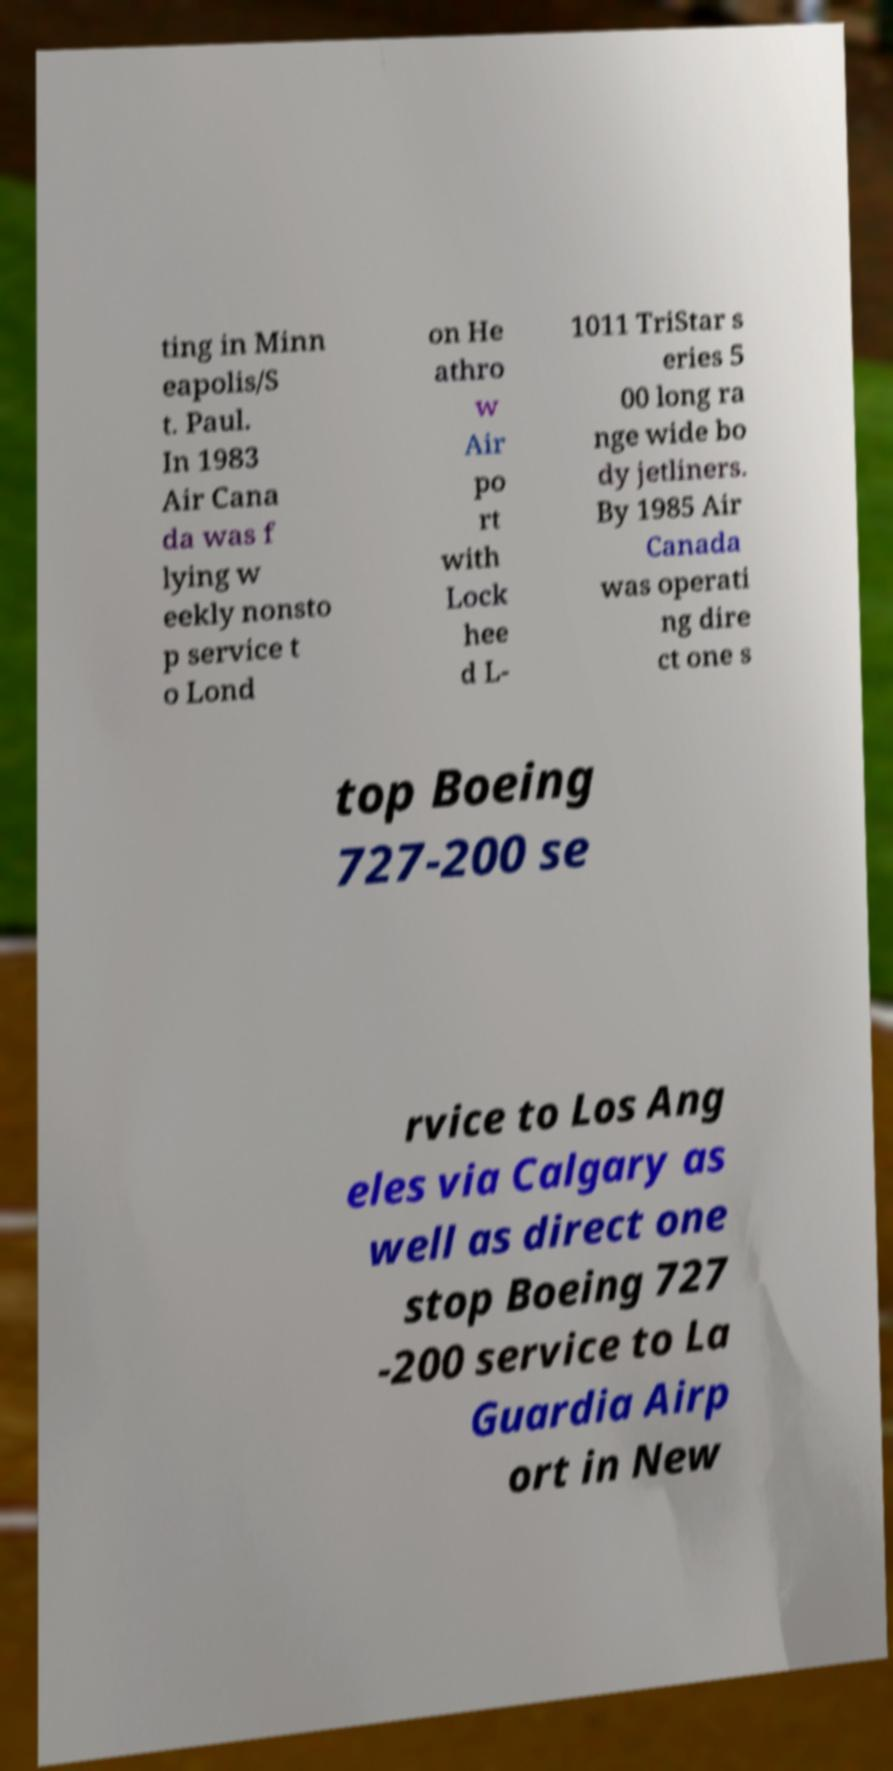What messages or text are displayed in this image? I need them in a readable, typed format. ting in Minn eapolis/S t. Paul. In 1983 Air Cana da was f lying w eekly nonsto p service t o Lond on He athro w Air po rt with Lock hee d L- 1011 TriStar s eries 5 00 long ra nge wide bo dy jetliners. By 1985 Air Canada was operati ng dire ct one s top Boeing 727-200 se rvice to Los Ang eles via Calgary as well as direct one stop Boeing 727 -200 service to La Guardia Airp ort in New 